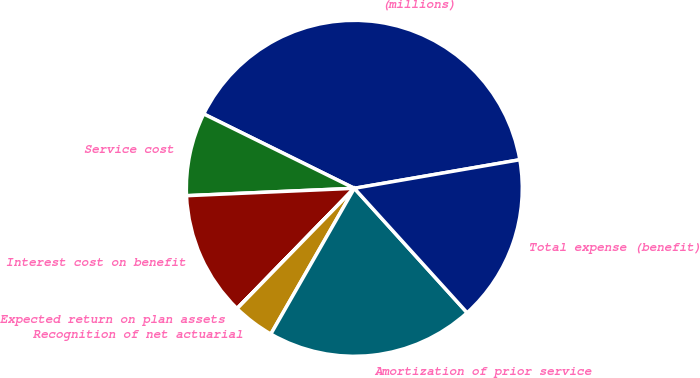Convert chart. <chart><loc_0><loc_0><loc_500><loc_500><pie_chart><fcel>(millions)<fcel>Service cost<fcel>Interest cost on benefit<fcel>Expected return on plan assets<fcel>Recognition of net actuarial<fcel>Amortization of prior service<fcel>Total expense (benefit)<nl><fcel>39.98%<fcel>8.0%<fcel>12.0%<fcel>0.01%<fcel>4.01%<fcel>20.0%<fcel>16.0%<nl></chart> 